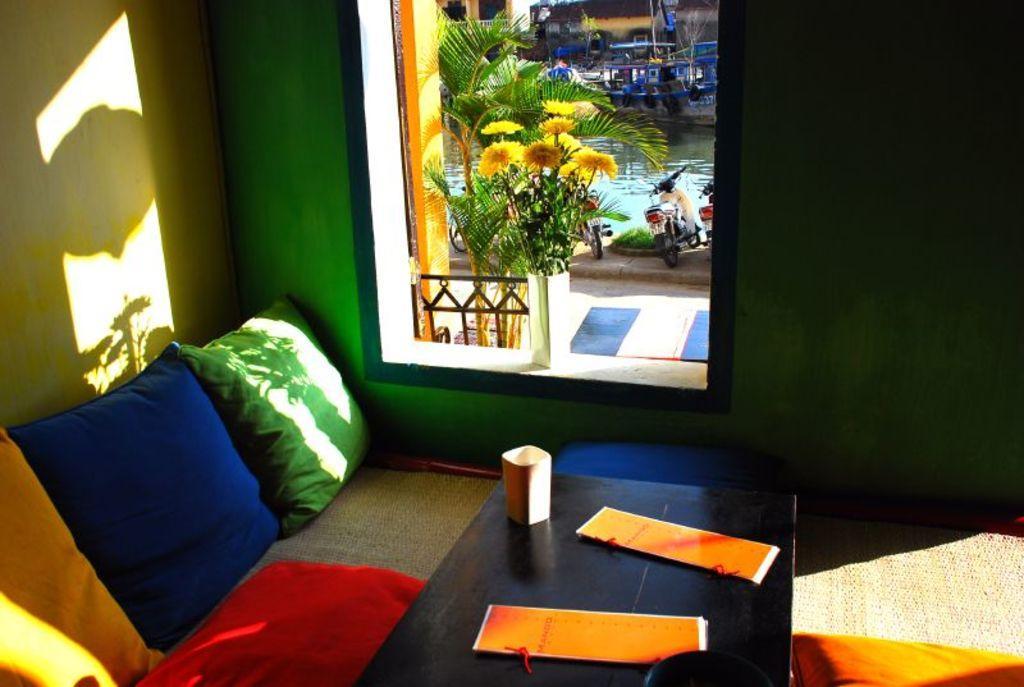Please provide a concise description of this image. In this picture there is a sofa with pillows with different colors. And there is a table. On the table there are two papers. And a window. Outside the window there are motorcycles, and water, boat. In the window there is a flower pot. 